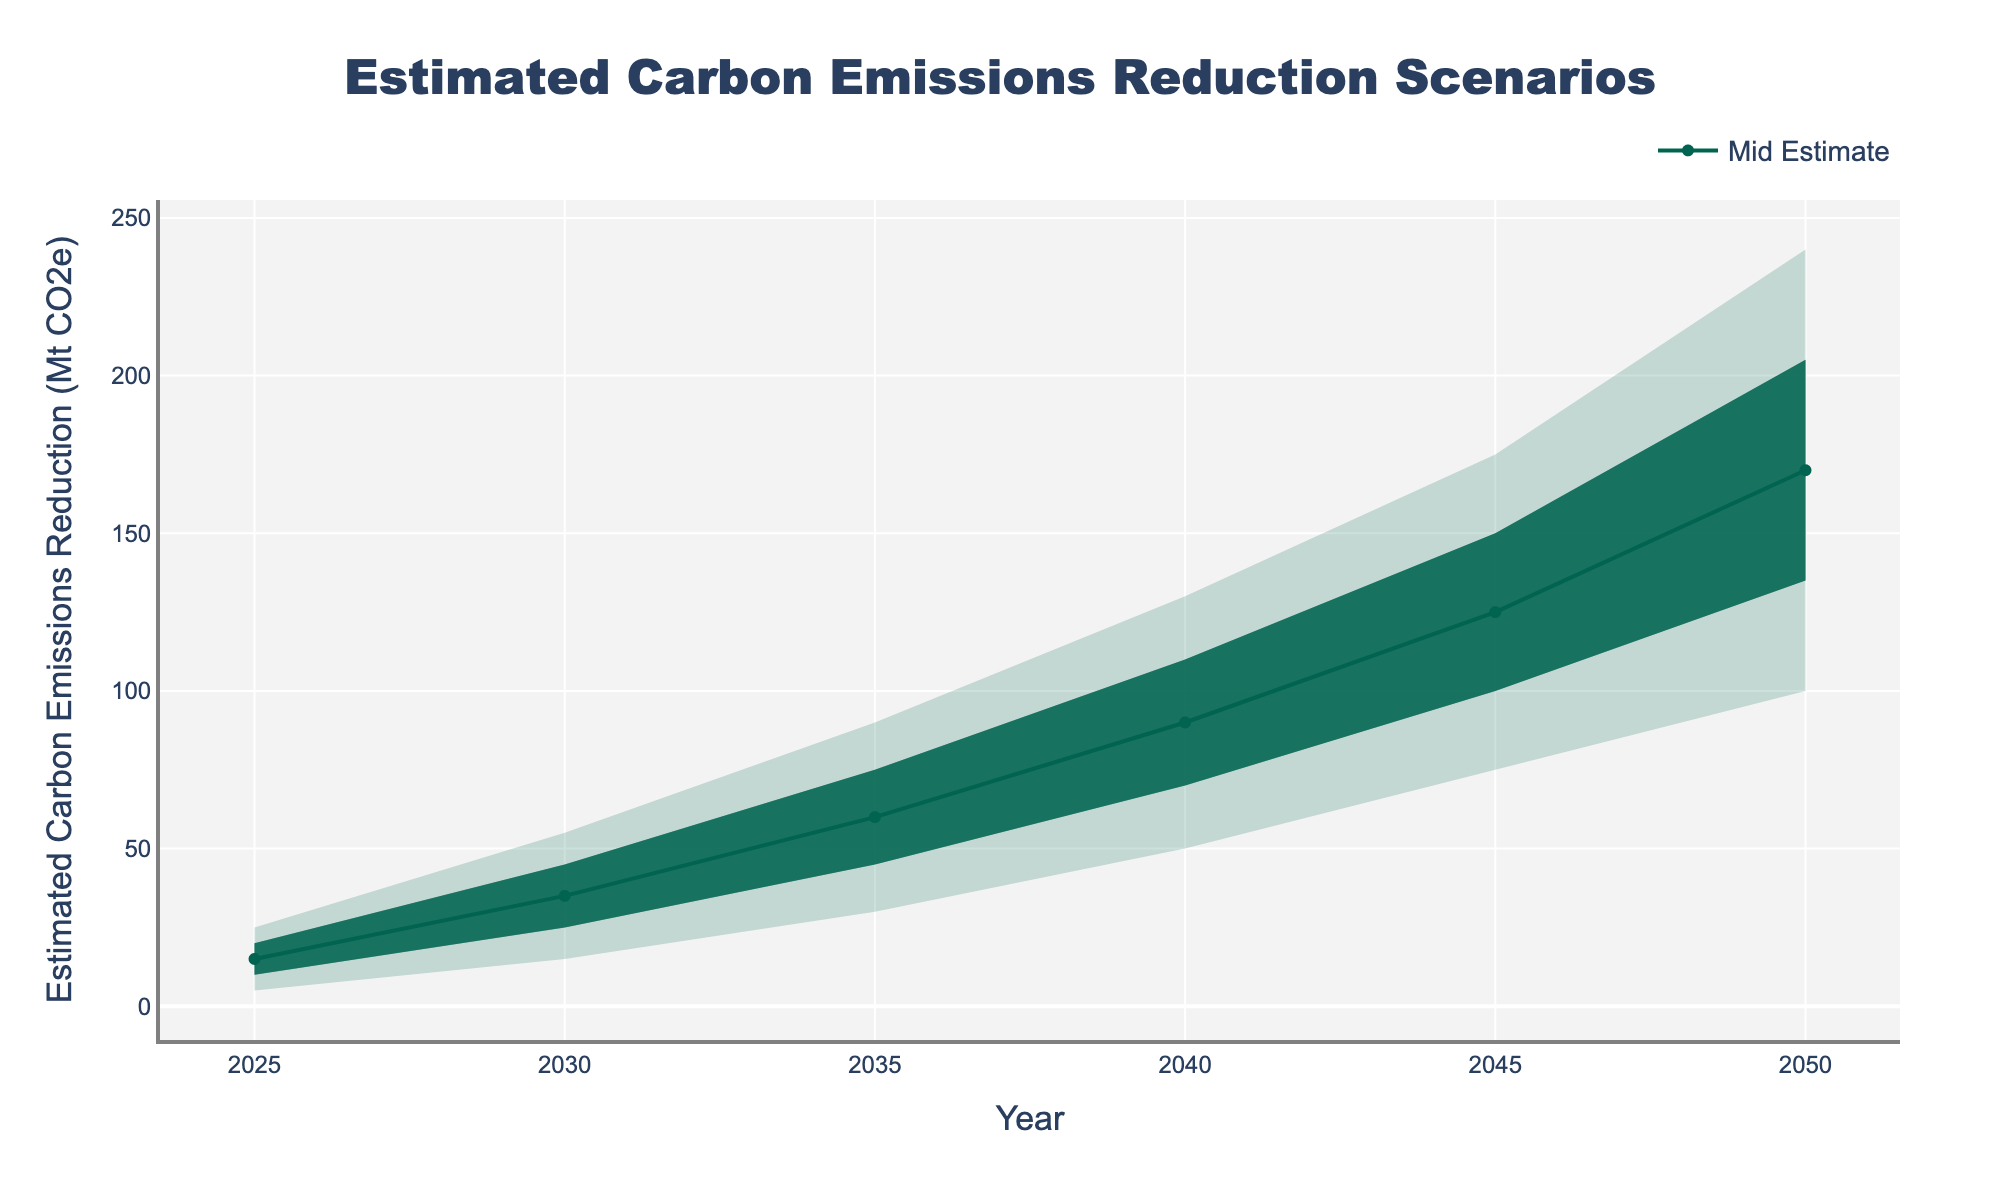What is the title of the figure? The title of the figure is typically placed at the top center of the chart. It summarizes the overall content and purpose of the chart.
Answer: Estimated Carbon Emissions Reduction Scenarios Which year shows a Mid Estimate of 90 Mt CO2e reduction in emissions? To find this, locate the "Mid Estimate" line and find where it intersects with 90 on the y-axis and then look down to the corresponding x-axis value (Year).
Answer: 2040 What is the range of the carbon emissions reduction in 2030 according to the high and low estimates? At the year 2030, the Low Estimate is 15 Mt CO2e and the High Estimate is 55 Mt CO2e, so the range is calculated as the difference between these estimates.
Answer: 40 Mt CO2e How much does the Mid Estimate for carbon emissions reduction increase from 2025 to 2050? The Mid Estimate in 2025 is 15 Mt CO2e and in 2050, it is 170 Mt CO2e. Subtract the 2025 value from the 2050 value to get the increase.
Answer: 155 Mt CO2e In which year does the Low-Mid Estimate reach 135 Mt CO2e? Identify the year on the x-axis where the "Low-Mid Estimate" line is at 135 Mt CO2e on the y-axis.
Answer: 2050 By how much does the Mid-High Estimate exceed the Low Estimate in 2045? For the year 2045, find the values for the Mid-High Estimate (150 Mt CO2e) and Low Estimate (75 Mt CO2e), then calculate the difference.
Answer: 75 Mt CO2e Compare the change in the Low Estimate between 2025 and 2035. The Low Estimate in 2025 is 5 Mt CO2e and in 2035 is 30 Mt CO2e. The difference between these years indicates how much it has increased.
Answer: 25 Mt CO2e Between which years does the High Estimate pass 200 Mt CO2e for the first time? Look for the first year when the High Estimate surpasses 200 Mt CO2e on the y-axis, which happens between consecutive years.
Answer: Between 2045 and 2050 Which estimate values (Low, Low-Mid, Mid, Mid-High, High) are the same in 2025? All estimate lines typically diverge as we progress through the timeline, but at the beginning year (2025), compare the values for each estimate type.
Answer: None are the same 